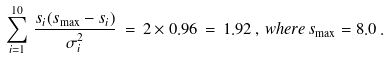Convert formula to latex. <formula><loc_0><loc_0><loc_500><loc_500>\sum _ { i = 1 } ^ { 1 0 } \, \frac { s _ { i } ( s _ { \max } - s _ { i } ) } { \sigma _ { i } ^ { 2 } } \, = \, 2 \times 0 . 9 6 \, = \, 1 . 9 2 \, , \, w h e r e \, s _ { \max } = 8 . 0 \, .</formula> 